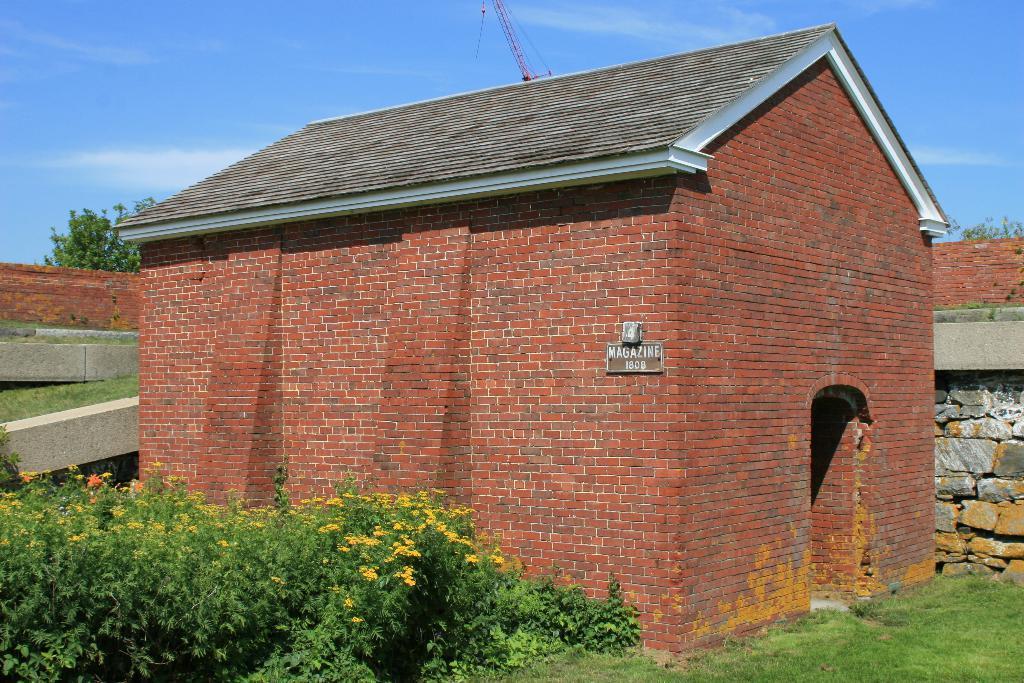In one or two sentences, can you explain what this image depicts? In this picture we can see a few plants, flowers, some text and numbers on the board visible on the house. We can see some grass on the ground. There are other objects, trees and the sky. 